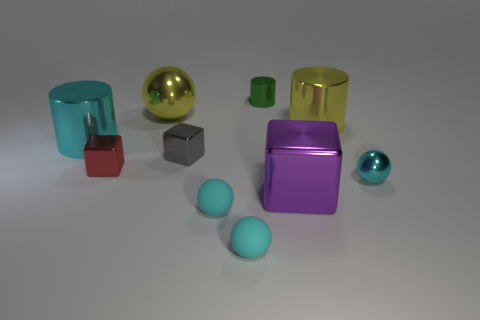How many cyan spheres must be subtracted to get 1 cyan spheres? 2 Subtract all blue cubes. How many cyan spheres are left? 3 Subtract all small gray cubes. How many cubes are left? 2 Subtract 2 balls. How many balls are left? 2 Subtract all cylinders. How many objects are left? 7 Subtract all yellow spheres. How many spheres are left? 3 Add 5 big metallic cubes. How many big metallic cubes are left? 6 Add 5 large shiny balls. How many large shiny balls exist? 6 Subtract 0 brown balls. How many objects are left? 10 Subtract all yellow cylinders. Subtract all yellow spheres. How many cylinders are left? 2 